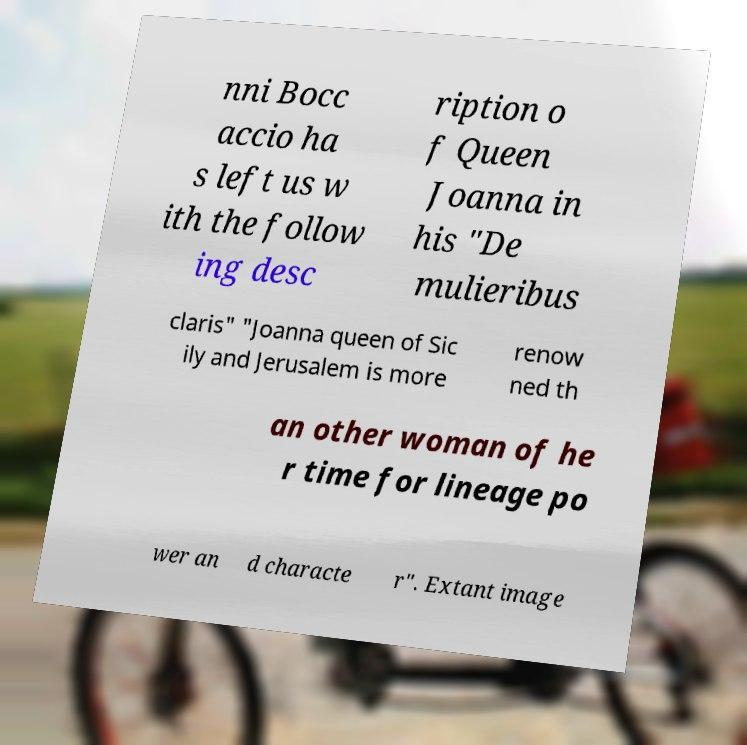Please identify and transcribe the text found in this image. nni Bocc accio ha s left us w ith the follow ing desc ription o f Queen Joanna in his "De mulieribus claris" "Joanna queen of Sic ily and Jerusalem is more renow ned th an other woman of he r time for lineage po wer an d characte r". Extant image 